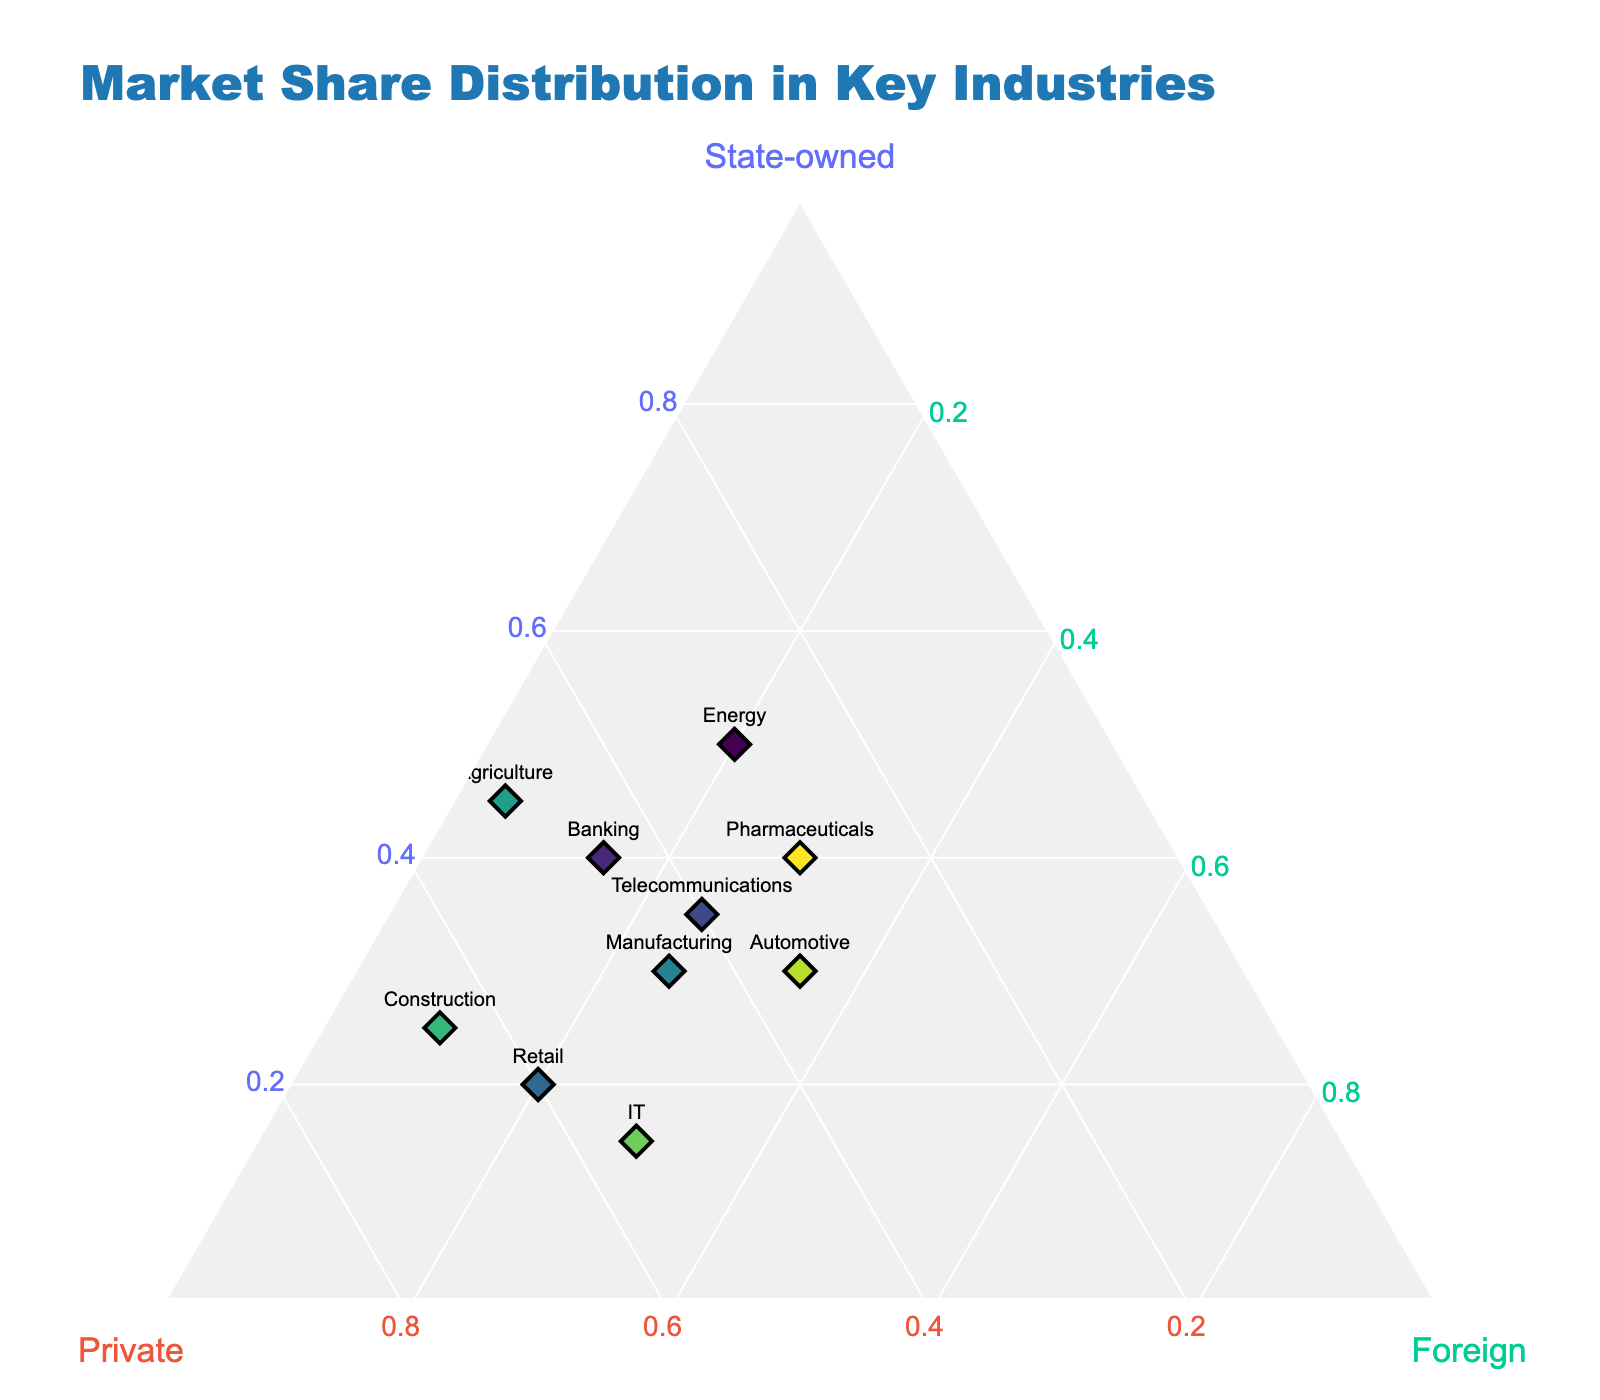What is the title of the figure? The title of the figure is located at the top and usually describes the main content or purpose of the chart. It reads "Market Share Distribution in Key Industries."
Answer: Market Share Distribution in Key Industries How many data points are there in the ternary plot? The number of data points corresponds to the number of industries listed and plotted in the figure. The dataset contains 10 industries, so there are 10 data points.
Answer: 10 Which industry has the highest percentage of state-owned companies? By locating the point that lies closest to the 'State-owned' axis, we identify that the Energy industry has the highest percentage at 50%.
Answer: Energy What is the combined market share of private and foreign companies in the IT industry? For the IT industry, add the percentage of private companies (55%) and foreign companies (30%). The combined market share is 55% + 30% = 85%.
Answer: 85% In which industry is the market share of state-owned companies equal to the market share of private companies? We look for points where the values for state-owned companies and private companies are equal. This occurs in the Agriculture industry, with both having a market share of 45%.
Answer: Agriculture Which industry has the smallest share of foreign companies, and what is that share? The industry with the smallest foreign share is identified by the point closest to the 'Foreign' axis minimum. The Agriculture industry has the smallest foreign share at 5%.
Answer: Agriculture, 5% Compare the market shares of state-owned companies in Banking and Pharmaceuticals industries. Which one is higher? Look at the state-owned axis percentages for both industries: Banking is at 40% and Pharmaceuticals is at 40%. Since they are equal, there is no higher value.
Answer: Both are equal What is the total market share for the Telecommunications industry across all company types? For the Telecommunications industry, add the market shares of state-owned (35%), private (40%), and foreign companies (25%). The total is 35% + 40% + 25% = 100%.
Answer: 100% Which industry has the highest percentage of private companies, and what is that percentage? Identify the point closest to the 'Private' axis maximum. The Construction industry has the highest percentage of private companies at 65%.
Answer: Construction, 65% How does the market share distribution compare between the Energy and Automotive industries in terms of state-owned and foreign companies? Energy has 50% state-owned and 20% foreign while Automotive has 30% state-owned and 35% foreign. Comparing these, Energy has a higher state-owned share (50% vs 30%), while Automotive has a higher foreign share (35% vs 20%).
Answer: Energy has higher state-owned, Automotive has higher foreign 